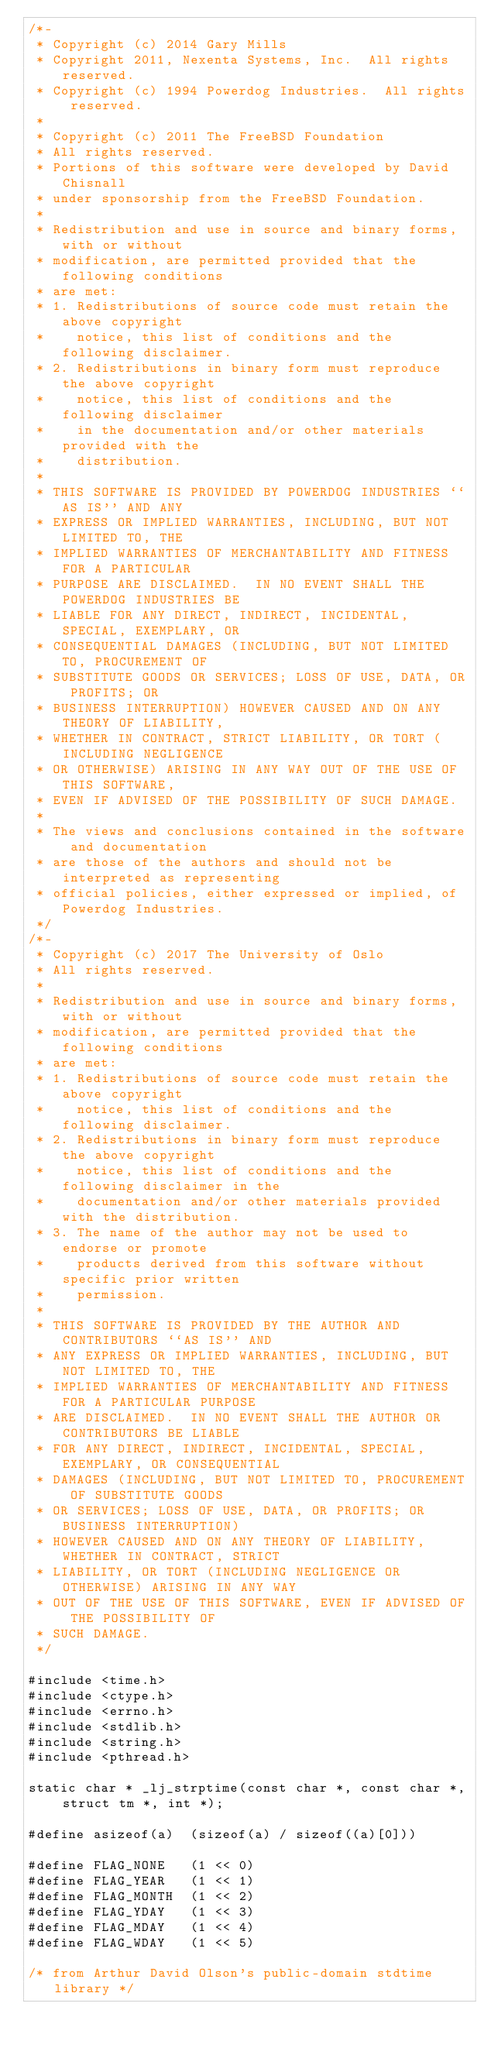<code> <loc_0><loc_0><loc_500><loc_500><_C_>/*-
 * Copyright (c) 2014 Gary Mills
 * Copyright 2011, Nexenta Systems, Inc.  All rights reserved.
 * Copyright (c) 1994 Powerdog Industries.  All rights reserved.
 *
 * Copyright (c) 2011 The FreeBSD Foundation
 * All rights reserved.
 * Portions of this software were developed by David Chisnall
 * under sponsorship from the FreeBSD Foundation.
 *
 * Redistribution and use in source and binary forms, with or without
 * modification, are permitted provided that the following conditions
 * are met:
 * 1. Redistributions of source code must retain the above copyright
 *    notice, this list of conditions and the following disclaimer.
 * 2. Redistributions in binary form must reproduce the above copyright
 *    notice, this list of conditions and the following disclaimer
 *    in the documentation and/or other materials provided with the
 *    distribution.
 *
 * THIS SOFTWARE IS PROVIDED BY POWERDOG INDUSTRIES ``AS IS'' AND ANY
 * EXPRESS OR IMPLIED WARRANTIES, INCLUDING, BUT NOT LIMITED TO, THE
 * IMPLIED WARRANTIES OF MERCHANTABILITY AND FITNESS FOR A PARTICULAR
 * PURPOSE ARE DISCLAIMED.  IN NO EVENT SHALL THE POWERDOG INDUSTRIES BE
 * LIABLE FOR ANY DIRECT, INDIRECT, INCIDENTAL, SPECIAL, EXEMPLARY, OR
 * CONSEQUENTIAL DAMAGES (INCLUDING, BUT NOT LIMITED TO, PROCUREMENT OF
 * SUBSTITUTE GOODS OR SERVICES; LOSS OF USE, DATA, OR PROFITS; OR
 * BUSINESS INTERRUPTION) HOWEVER CAUSED AND ON ANY THEORY OF LIABILITY,
 * WHETHER IN CONTRACT, STRICT LIABILITY, OR TORT (INCLUDING NEGLIGENCE
 * OR OTHERWISE) ARISING IN ANY WAY OUT OF THE USE OF THIS SOFTWARE,
 * EVEN IF ADVISED OF THE POSSIBILITY OF SUCH DAMAGE.
 *
 * The views and conclusions contained in the software and documentation
 * are those of the authors and should not be interpreted as representing
 * official policies, either expressed or implied, of Powerdog Industries.
 */
/*-
 * Copyright (c) 2017 The University of Oslo
 * All rights reserved.
 *
 * Redistribution and use in source and binary forms, with or without
 * modification, are permitted provided that the following conditions
 * are met:
 * 1. Redistributions of source code must retain the above copyright
 *    notice, this list of conditions and the following disclaimer.
 * 2. Redistributions in binary form must reproduce the above copyright
 *    notice, this list of conditions and the following disclaimer in the
 *    documentation and/or other materials provided with the distribution.
 * 3. The name of the author may not be used to endorse or promote
 *    products derived from this software without specific prior written
 *    permission.
 *
 * THIS SOFTWARE IS PROVIDED BY THE AUTHOR AND CONTRIBUTORS ``AS IS'' AND
 * ANY EXPRESS OR IMPLIED WARRANTIES, INCLUDING, BUT NOT LIMITED TO, THE
 * IMPLIED WARRANTIES OF MERCHANTABILITY AND FITNESS FOR A PARTICULAR PURPOSE
 * ARE DISCLAIMED.  IN NO EVENT SHALL THE AUTHOR OR CONTRIBUTORS BE LIABLE
 * FOR ANY DIRECT, INDIRECT, INCIDENTAL, SPECIAL, EXEMPLARY, OR CONSEQUENTIAL
 * DAMAGES (INCLUDING, BUT NOT LIMITED TO, PROCUREMENT OF SUBSTITUTE GOODS
 * OR SERVICES; LOSS OF USE, DATA, OR PROFITS; OR BUSINESS INTERRUPTION)
 * HOWEVER CAUSED AND ON ANY THEORY OF LIABILITY, WHETHER IN CONTRACT, STRICT
 * LIABILITY, OR TORT (INCLUDING NEGLIGENCE OR OTHERWISE) ARISING IN ANY WAY
 * OUT OF THE USE OF THIS SOFTWARE, EVEN IF ADVISED OF THE POSSIBILITY OF
 * SUCH DAMAGE.
 */

#include <time.h>
#include <ctype.h>
#include <errno.h>
#include <stdlib.h>
#include <string.h>
#include <pthread.h>

static char * _lj_strptime(const char *, const char *, struct tm *, int *);

#define	asizeof(a)	(sizeof(a) / sizeof((a)[0]))

#define	FLAG_NONE	(1 << 0)
#define	FLAG_YEAR	(1 << 1)
#define	FLAG_MONTH	(1 << 2)
#define	FLAG_YDAY	(1 << 3)
#define	FLAG_MDAY	(1 << 4)
#define	FLAG_WDAY	(1 << 5)

/* from Arthur David Olson's public-domain stdtime library */</code> 